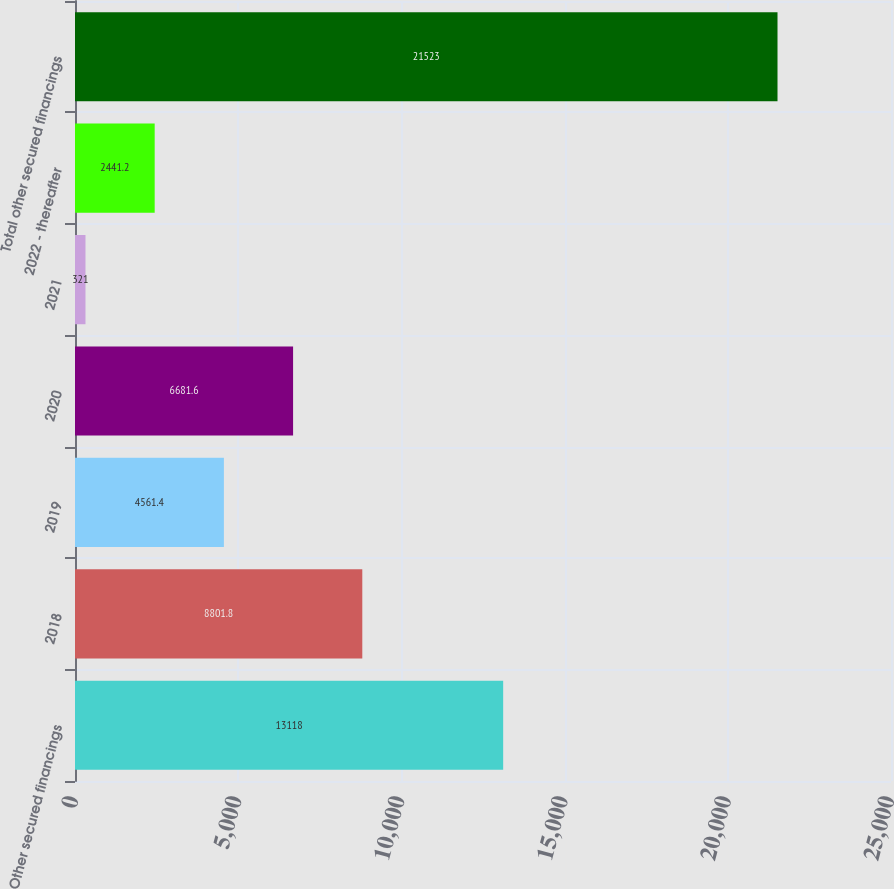<chart> <loc_0><loc_0><loc_500><loc_500><bar_chart><fcel>Other secured financings<fcel>2018<fcel>2019<fcel>2020<fcel>2021<fcel>2022 - thereafter<fcel>Total other secured financings<nl><fcel>13118<fcel>8801.8<fcel>4561.4<fcel>6681.6<fcel>321<fcel>2441.2<fcel>21523<nl></chart> 